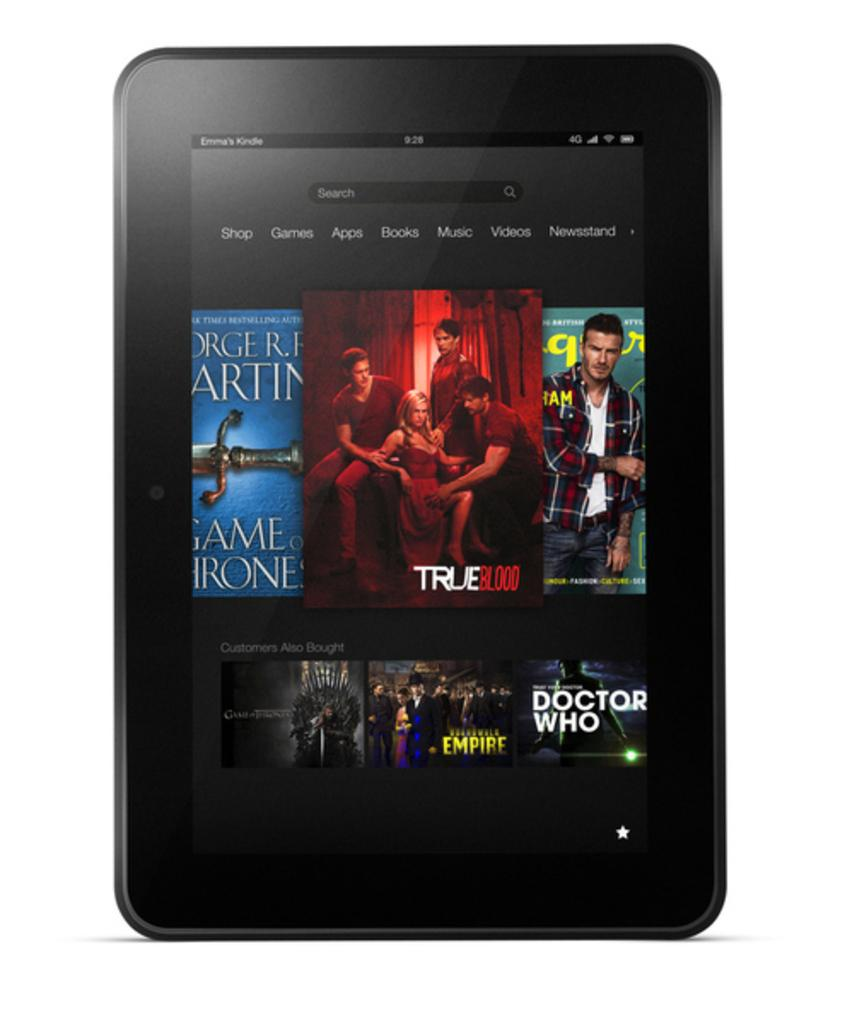What electronic device is present in the image? There is a tablet in the image. What is displayed on the screen of the tablet? Film posters are visible on the screen of the tablet. What type of hook is used by the laborer in the image? There is no laborer or hook present in the image; it only features a tablet with film posters on the screen. 